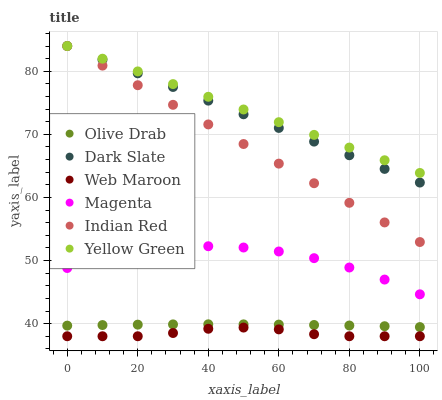Does Web Maroon have the minimum area under the curve?
Answer yes or no. Yes. Does Yellow Green have the maximum area under the curve?
Answer yes or no. Yes. Does Dark Slate have the minimum area under the curve?
Answer yes or no. No. Does Dark Slate have the maximum area under the curve?
Answer yes or no. No. Is Yellow Green the smoothest?
Answer yes or no. Yes. Is Magenta the roughest?
Answer yes or no. Yes. Is Web Maroon the smoothest?
Answer yes or no. No. Is Web Maroon the roughest?
Answer yes or no. No. Does Web Maroon have the lowest value?
Answer yes or no. Yes. Does Dark Slate have the lowest value?
Answer yes or no. No. Does Indian Red have the highest value?
Answer yes or no. Yes. Does Web Maroon have the highest value?
Answer yes or no. No. Is Magenta less than Dark Slate?
Answer yes or no. Yes. Is Dark Slate greater than Web Maroon?
Answer yes or no. Yes. Does Yellow Green intersect Dark Slate?
Answer yes or no. Yes. Is Yellow Green less than Dark Slate?
Answer yes or no. No. Is Yellow Green greater than Dark Slate?
Answer yes or no. No. Does Magenta intersect Dark Slate?
Answer yes or no. No. 